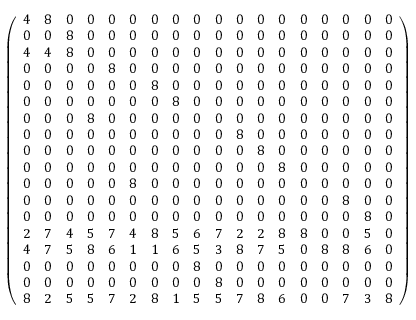<formula> <loc_0><loc_0><loc_500><loc_500>\left ( { \begin{array} { l l l l l l l l l l l l l l l l l l } { 4 } & { 8 } & { 0 } & { 0 } & { 0 } & { 0 } & { 0 } & { 0 } & { 0 } & { 0 } & { 0 } & { 0 } & { 0 } & { 0 } & { 0 } & { 0 } & { 0 } & { 0 } \\ { 0 } & { 0 } & { 8 } & { 0 } & { 0 } & { 0 } & { 0 } & { 0 } & { 0 } & { 0 } & { 0 } & { 0 } & { 0 } & { 0 } & { 0 } & { 0 } & { 0 } & { 0 } \\ { 4 } & { 4 } & { 8 } & { 0 } & { 0 } & { 0 } & { 0 } & { 0 } & { 0 } & { 0 } & { 0 } & { 0 } & { 0 } & { 0 } & { 0 } & { 0 } & { 0 } & { 0 } \\ { 0 } & { 0 } & { 0 } & { 0 } & { 8 } & { 0 } & { 0 } & { 0 } & { 0 } & { 0 } & { 0 } & { 0 } & { 0 } & { 0 } & { 0 } & { 0 } & { 0 } & { 0 } \\ { 0 } & { 0 } & { 0 } & { 0 } & { 0 } & { 0 } & { 8 } & { 0 } & { 0 } & { 0 } & { 0 } & { 0 } & { 0 } & { 0 } & { 0 } & { 0 } & { 0 } & { 0 } \\ { 0 } & { 0 } & { 0 } & { 0 } & { 0 } & { 0 } & { 0 } & { 8 } & { 0 } & { 0 } & { 0 } & { 0 } & { 0 } & { 0 } & { 0 } & { 0 } & { 0 } & { 0 } \\ { 0 } & { 0 } & { 0 } & { 8 } & { 0 } & { 0 } & { 0 } & { 0 } & { 0 } & { 0 } & { 0 } & { 0 } & { 0 } & { 0 } & { 0 } & { 0 } & { 0 } & { 0 } \\ { 0 } & { 0 } & { 0 } & { 0 } & { 0 } & { 0 } & { 0 } & { 0 } & { 0 } & { 0 } & { 8 } & { 0 } & { 0 } & { 0 } & { 0 } & { 0 } & { 0 } & { 0 } \\ { 0 } & { 0 } & { 0 } & { 0 } & { 0 } & { 0 } & { 0 } & { 0 } & { 0 } & { 0 } & { 0 } & { 8 } & { 0 } & { 0 } & { 0 } & { 0 } & { 0 } & { 0 } \\ { 0 } & { 0 } & { 0 } & { 0 } & { 0 } & { 0 } & { 0 } & { 0 } & { 0 } & { 0 } & { 0 } & { 0 } & { 8 } & { 0 } & { 0 } & { 0 } & { 0 } & { 0 } \\ { 0 } & { 0 } & { 0 } & { 0 } & { 0 } & { 8 } & { 0 } & { 0 } & { 0 } & { 0 } & { 0 } & { 0 } & { 0 } & { 0 } & { 0 } & { 0 } & { 0 } & { 0 } \\ { 0 } & { 0 } & { 0 } & { 0 } & { 0 } & { 0 } & { 0 } & { 0 } & { 0 } & { 0 } & { 0 } & { 0 } & { 0 } & { 0 } & { 0 } & { 8 } & { 0 } & { 0 } \\ { 0 } & { 0 } & { 0 } & { 0 } & { 0 } & { 0 } & { 0 } & { 0 } & { 0 } & { 0 } & { 0 } & { 0 } & { 0 } & { 0 } & { 0 } & { 0 } & { 8 } & { 0 } \\ { 2 } & { 7 } & { 4 } & { 5 } & { 7 } & { 4 } & { 8 } & { 5 } & { 6 } & { 7 } & { 2 } & { 2 } & { 8 } & { 8 } & { 0 } & { 0 } & { 5 } & { 0 } \\ { 4 } & { 7 } & { 5 } & { 8 } & { 6 } & { 1 } & { 1 } & { 6 } & { 5 } & { 3 } & { 8 } & { 7 } & { 5 } & { 0 } & { 8 } & { 8 } & { 6 } & { 0 } \\ { 0 } & { 0 } & { 0 } & { 0 } & { 0 } & { 0 } & { 0 } & { 0 } & { 8 } & { 0 } & { 0 } & { 0 } & { 0 } & { 0 } & { 0 } & { 0 } & { 0 } & { 0 } \\ { 0 } & { 0 } & { 0 } & { 0 } & { 0 } & { 0 } & { 0 } & { 0 } & { 0 } & { 8 } & { 0 } & { 0 } & { 0 } & { 0 } & { 0 } & { 0 } & { 0 } & { 0 } \\ { 8 } & { 2 } & { 5 } & { 5 } & { 7 } & { 2 } & { 8 } & { 1 } & { 5 } & { 5 } & { 7 } & { 8 } & { 6 } & { 0 } & { 0 } & { 7 } & { 3 } & { 8 } \end{array} } \right )</formula> 